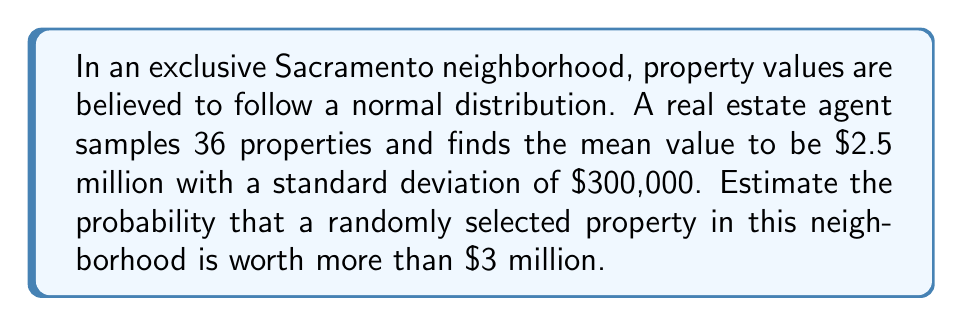Solve this math problem. Let's approach this step-by-step:

1) We're dealing with a normal distribution where:
   $\mu = 2.5$ million
   $\sigma = 300,000$

2) We want to find $P(X > 3,000,000)$, where $X$ is the property value.

3) To use the standard normal distribution, we need to standardize our value:
   $z = \frac{x - \mu}{\sigma}$

4) Calculating z for $3,000,000:
   z = \frac{3,000,000 - 2,500,000}{300,000} = \frac{500,000}{300,000} = 1.67$

5) Now we need to find $P(Z > 1.67)$ in the standard normal table.

6) From the standard normal table, we find that $P(Z < 1.67) \approx 0.9525$

7) Since we want the probability of being greater than 1.67:
   $P(Z > 1.67) = 1 - P(Z < 1.67) = 1 - 0.9525 = 0.0475$

8) Therefore, the probability of a randomly selected property being worth more than $3 million is approximately 0.0475 or 4.75%.
Answer: $0.0475$ or $4.75\%$ 